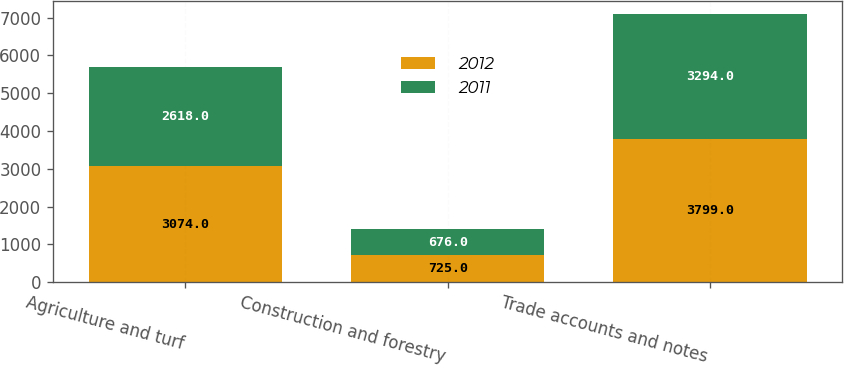Convert chart. <chart><loc_0><loc_0><loc_500><loc_500><stacked_bar_chart><ecel><fcel>Agriculture and turf<fcel>Construction and forestry<fcel>Trade accounts and notes<nl><fcel>2012<fcel>3074<fcel>725<fcel>3799<nl><fcel>2011<fcel>2618<fcel>676<fcel>3294<nl></chart> 